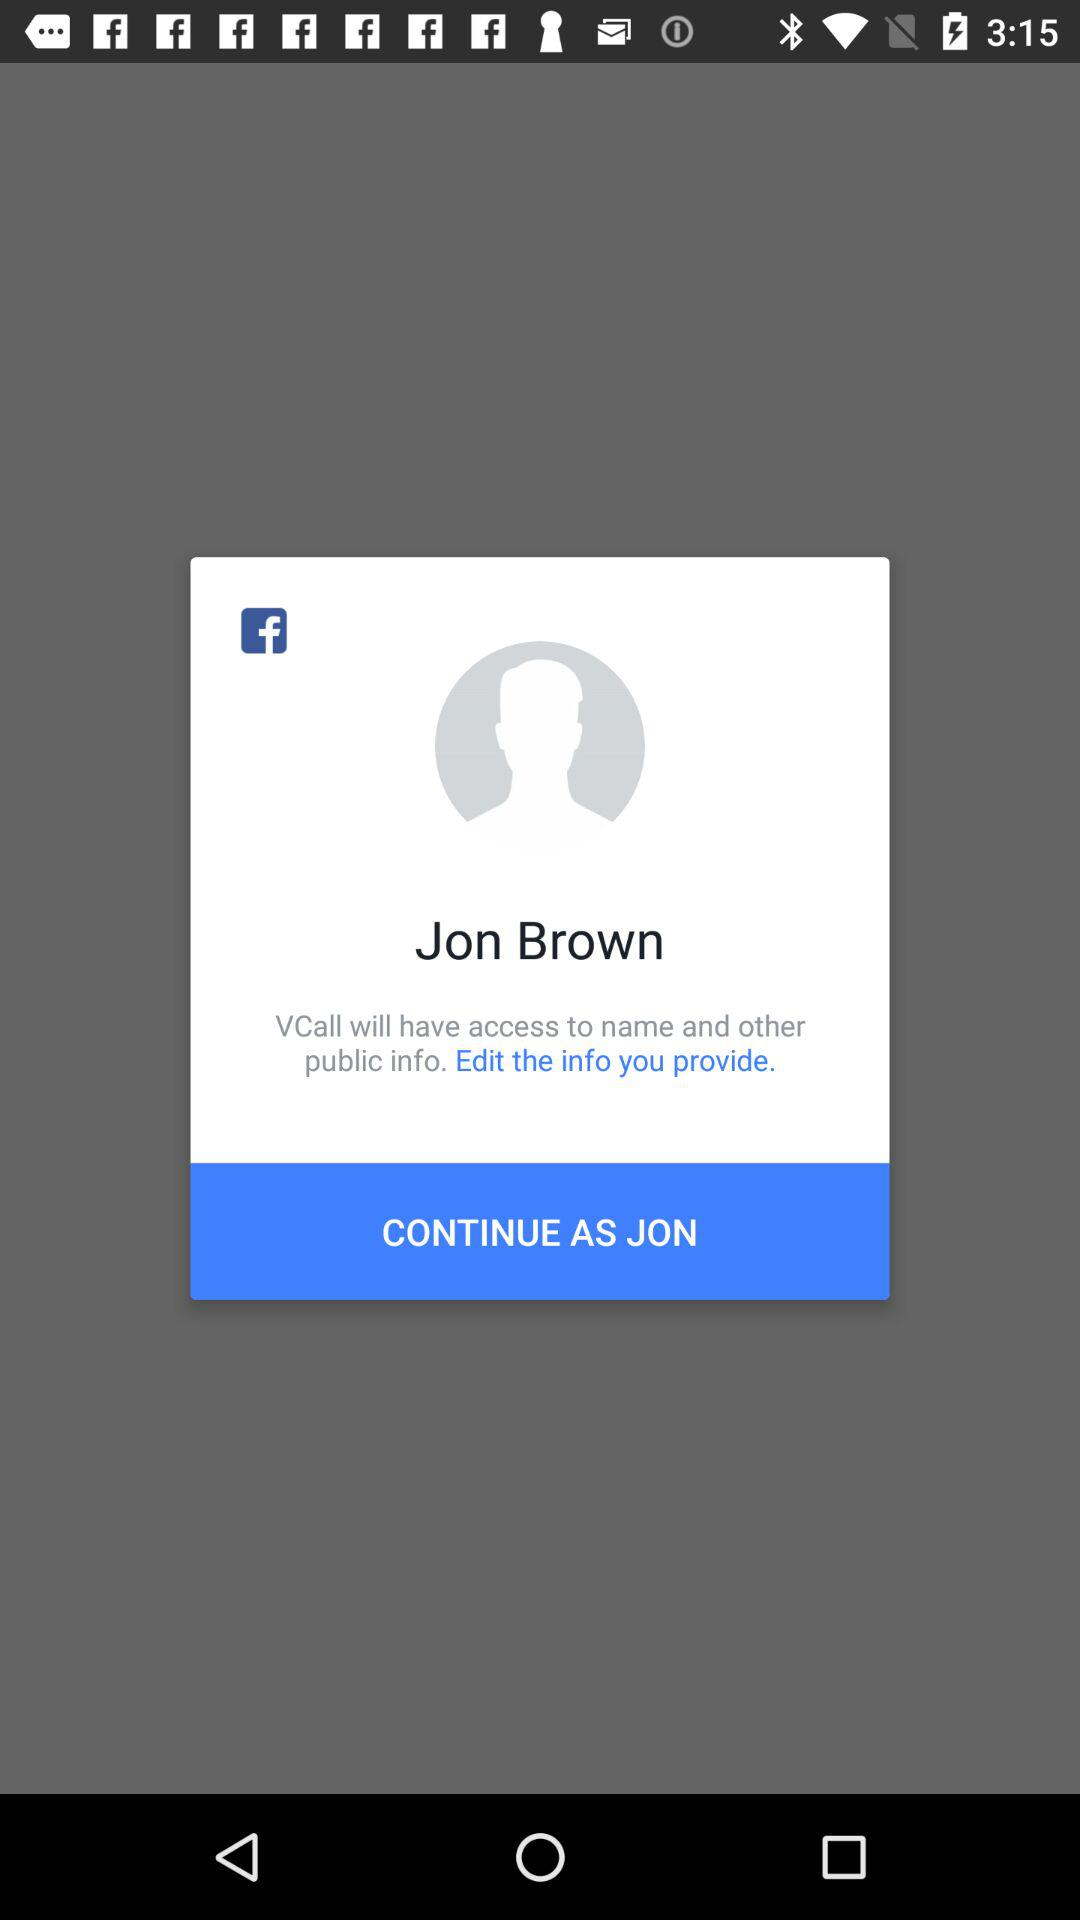Through what application can the user continue? The user can continue through "Facebook". 